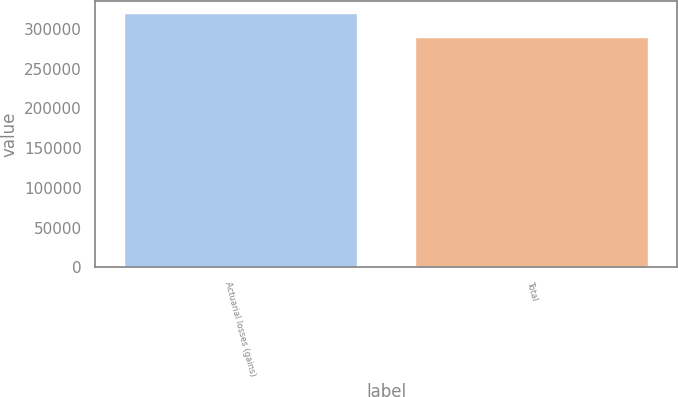Convert chart. <chart><loc_0><loc_0><loc_500><loc_500><bar_chart><fcel>Actuarial losses (gains)<fcel>Total<nl><fcel>319770<fcel>289628<nl></chart> 